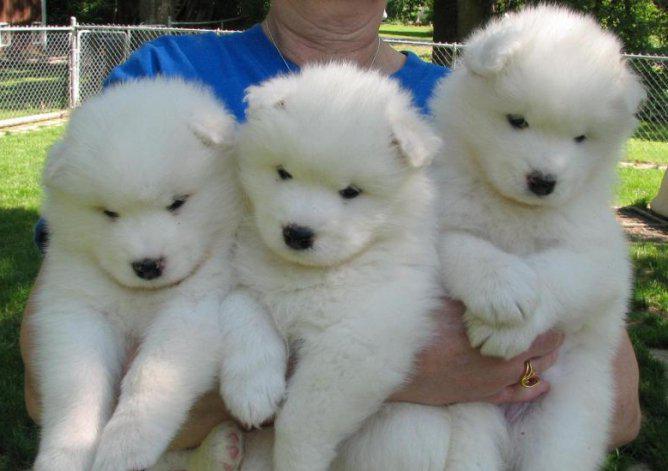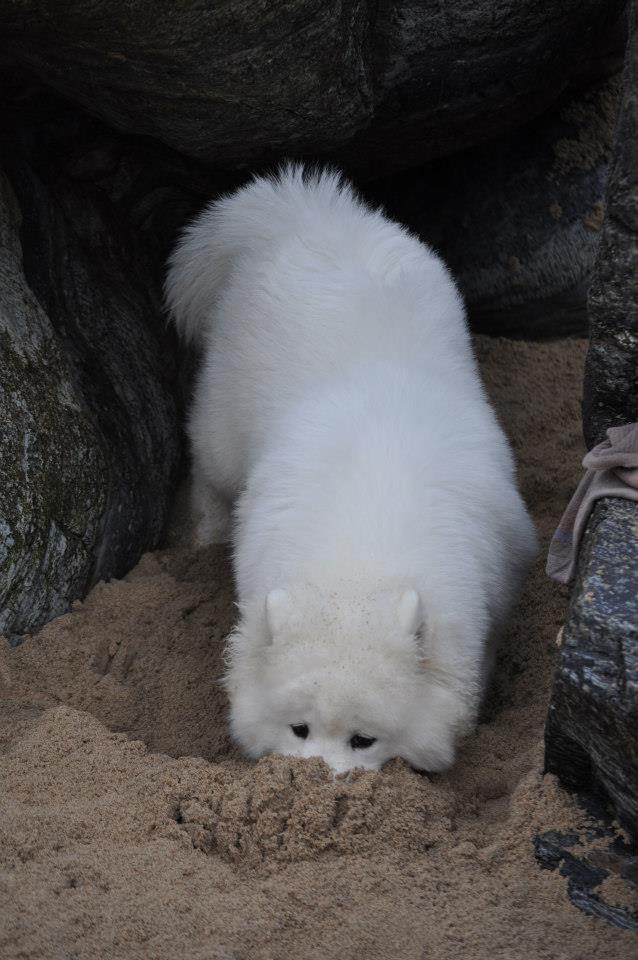The first image is the image on the left, the second image is the image on the right. Given the left and right images, does the statement "An image shows one person behind three white dogs." hold true? Answer yes or no. Yes. The first image is the image on the left, the second image is the image on the right. Examine the images to the left and right. Is the description "There are three Samoyed puppies in the left image." accurate? Answer yes or no. Yes. 